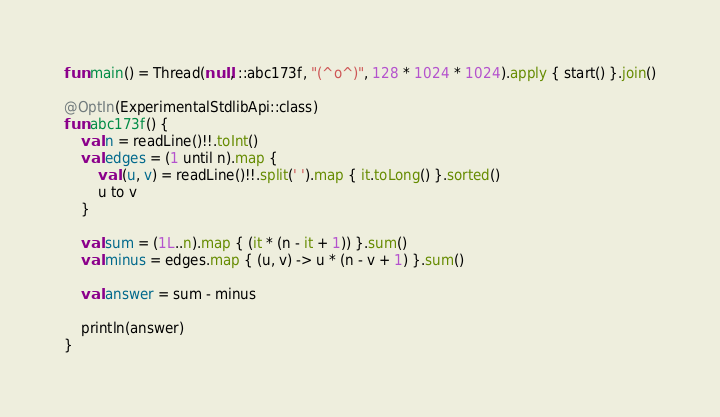<code> <loc_0><loc_0><loc_500><loc_500><_Kotlin_>fun main() = Thread(null, ::abc173f, "(^o^)", 128 * 1024 * 1024).apply { start() }.join()

@OptIn(ExperimentalStdlibApi::class)
fun abc173f() {
    val n = readLine()!!.toInt()
    val edges = (1 until n).map {
        val (u, v) = readLine()!!.split(' ').map { it.toLong() }.sorted()
        u to v
    }

    val sum = (1L..n).map { (it * (n - it + 1)) }.sum()
    val minus = edges.map { (u, v) -> u * (n - v + 1) }.sum()

    val answer = sum - minus

    println(answer)
}
</code> 